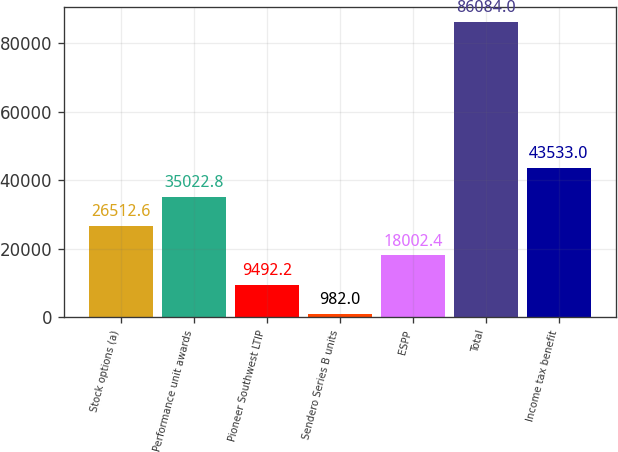<chart> <loc_0><loc_0><loc_500><loc_500><bar_chart><fcel>Stock options (a)<fcel>Performance unit awards<fcel>Pioneer Southwest LTIP<fcel>Sendero Series B units<fcel>ESPP<fcel>Total<fcel>Income tax benefit<nl><fcel>26512.6<fcel>35022.8<fcel>9492.2<fcel>982<fcel>18002.4<fcel>86084<fcel>43533<nl></chart> 